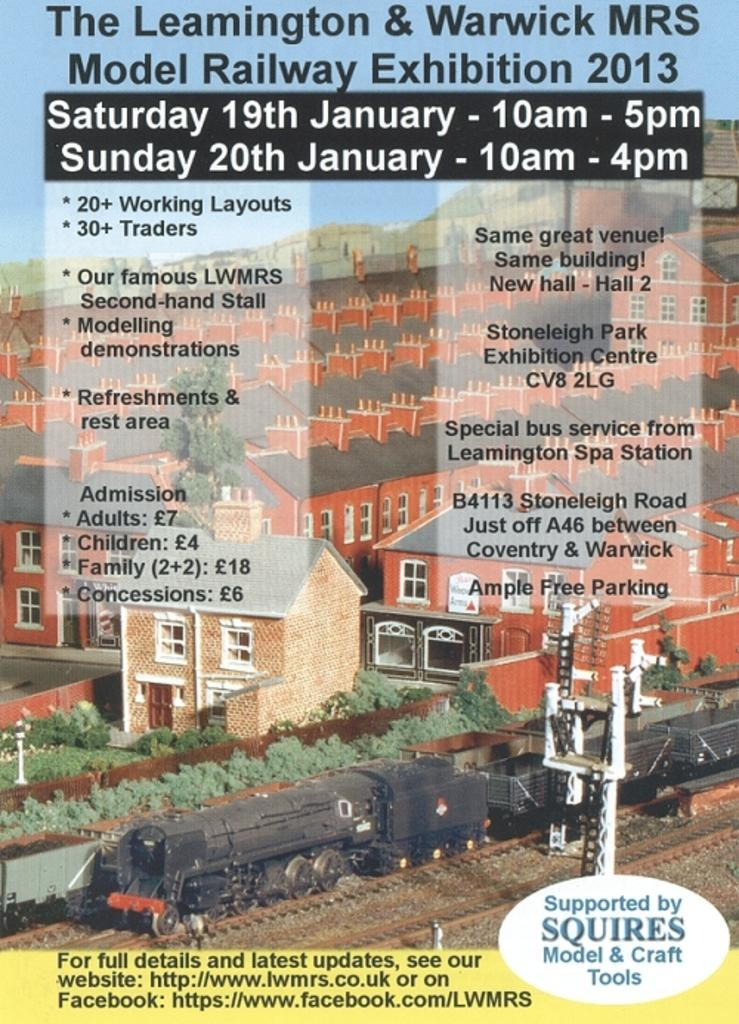Provide a one-sentence caption for the provided image. A flyer talking about the leamington & Warwick MRS. 